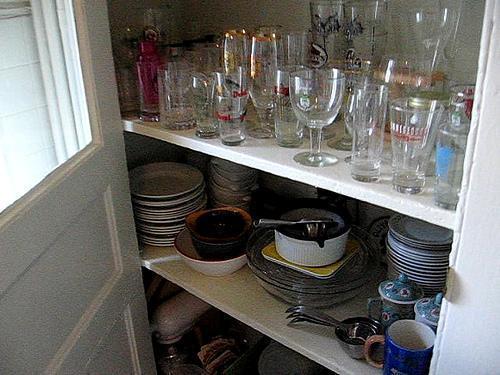Where are these items being stored?
Indicate the correct response by choosing from the four available options to answer the question.
Options: Refrigerator, cabinet, shed, box. Cabinet. 